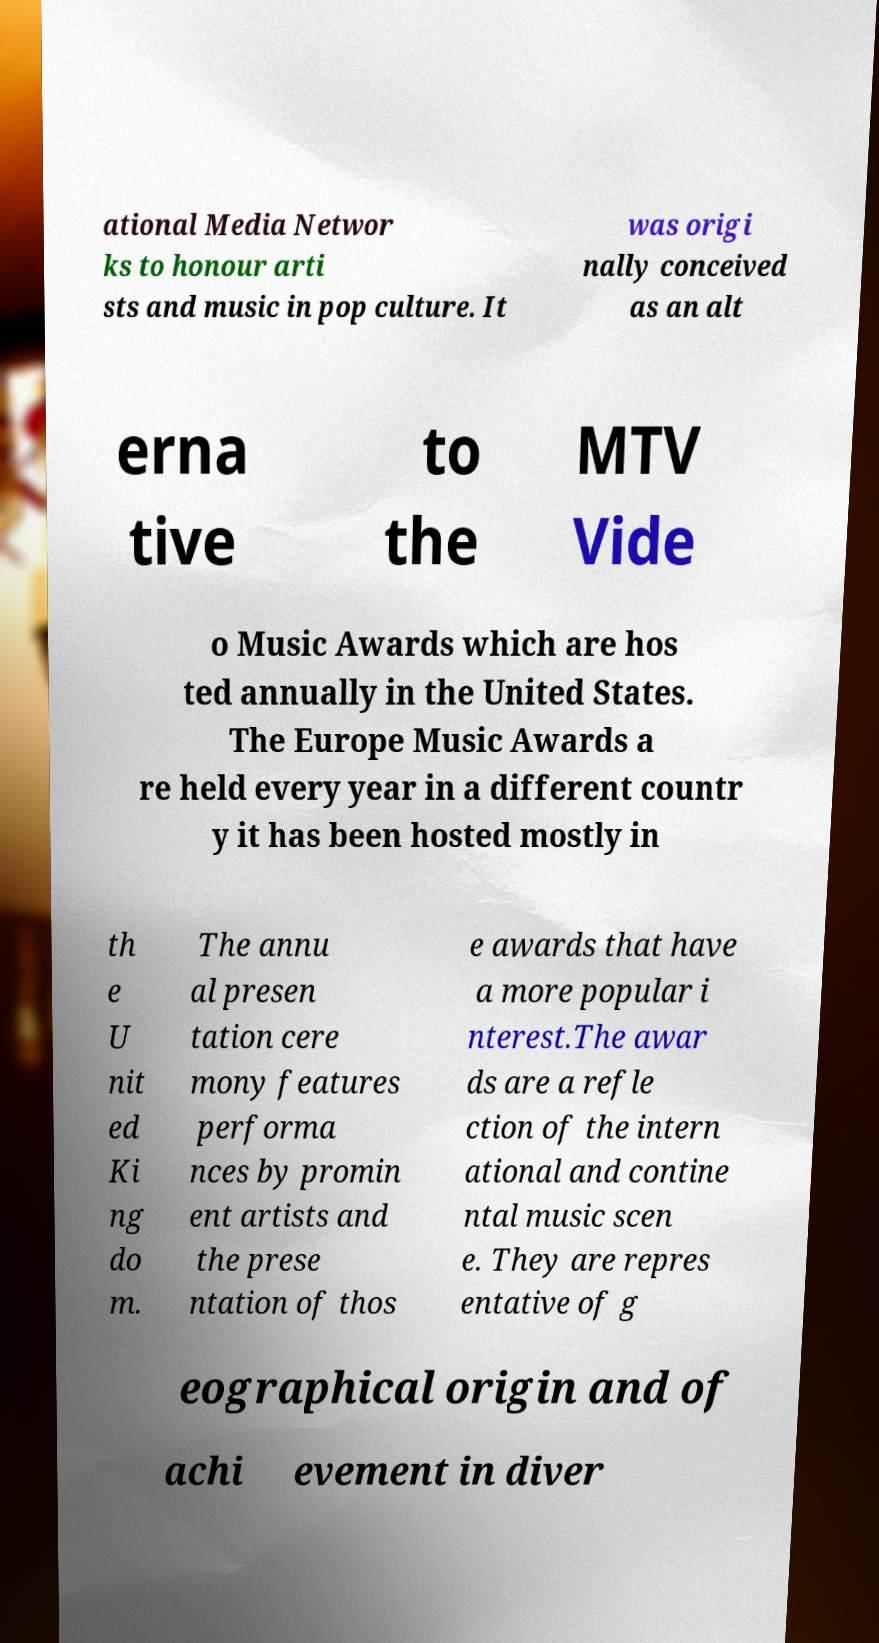Could you assist in decoding the text presented in this image and type it out clearly? ational Media Networ ks to honour arti sts and music in pop culture. It was origi nally conceived as an alt erna tive to the MTV Vide o Music Awards which are hos ted annually in the United States. The Europe Music Awards a re held every year in a different countr y it has been hosted mostly in th e U nit ed Ki ng do m. The annu al presen tation cere mony features performa nces by promin ent artists and the prese ntation of thos e awards that have a more popular i nterest.The awar ds are a refle ction of the intern ational and contine ntal music scen e. They are repres entative of g eographical origin and of achi evement in diver 